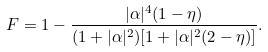<formula> <loc_0><loc_0><loc_500><loc_500>F = 1 - \frac { | \alpha | ^ { 4 } ( 1 - \eta ) } { ( 1 + | \alpha | ^ { 2 } ) [ 1 + | \alpha | ^ { 2 } ( 2 - \eta ) ] } .</formula> 